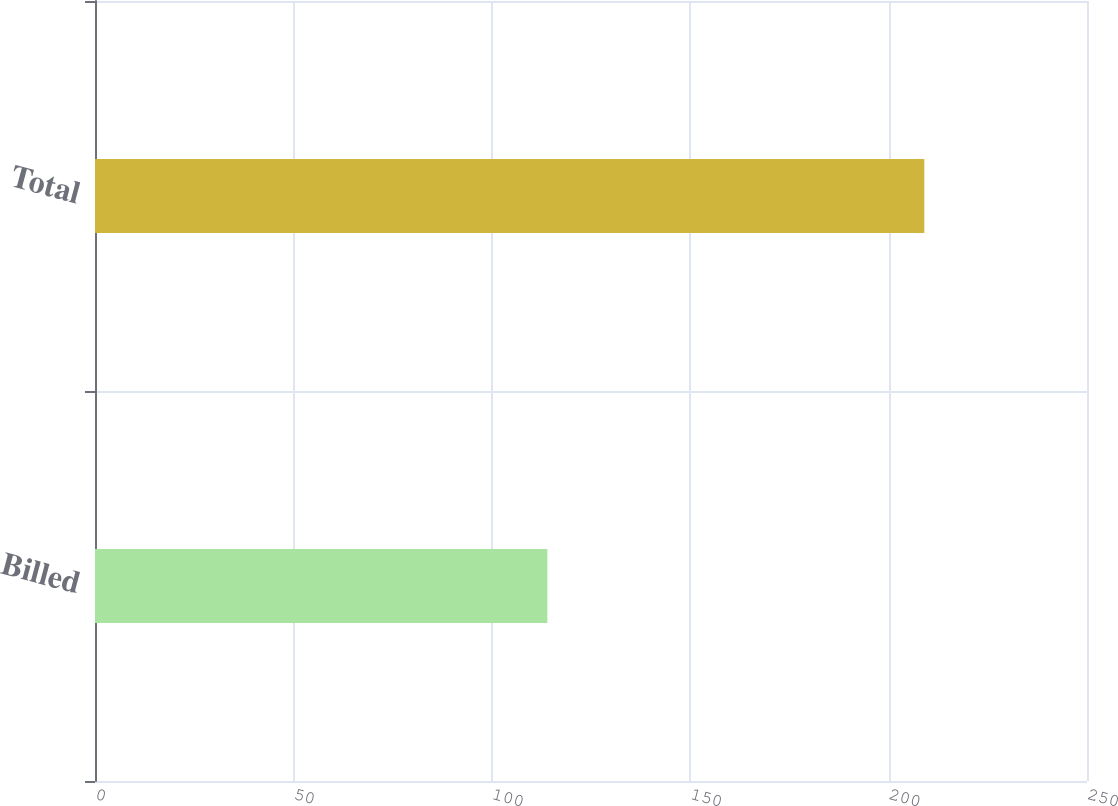Convert chart to OTSL. <chart><loc_0><loc_0><loc_500><loc_500><bar_chart><fcel>Billed<fcel>Total<nl><fcel>114<fcel>209<nl></chart> 